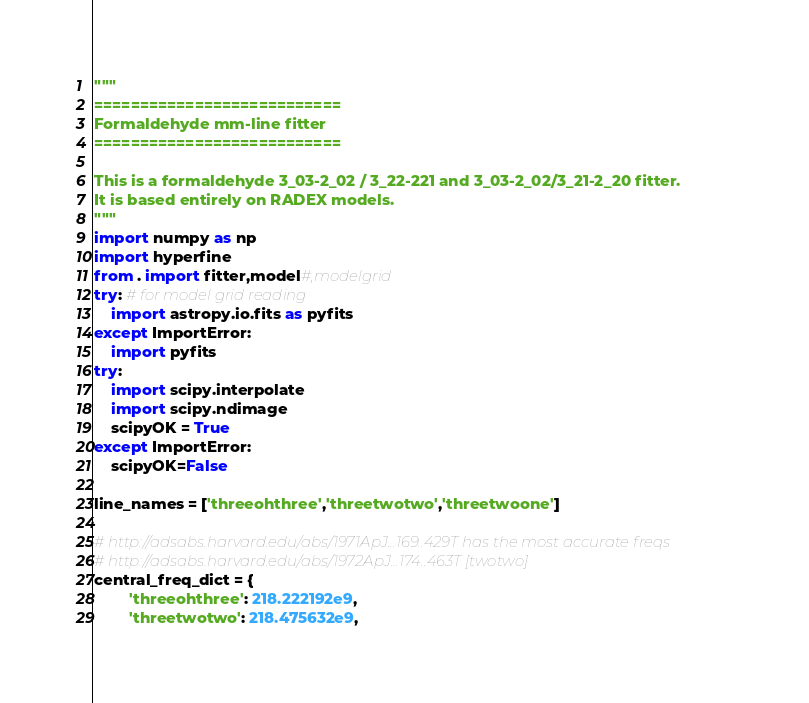Convert code to text. <code><loc_0><loc_0><loc_500><loc_500><_Python_>"""
===========================
Formaldehyde mm-line fitter
===========================

This is a formaldehyde 3_03-2_02 / 3_22-221 and 3_03-2_02/3_21-2_20 fitter.  
It is based entirely on RADEX models.
"""
import numpy as np
import hyperfine
from . import fitter,model#,modelgrid
try: # for model grid reading
    import astropy.io.fits as pyfits
except ImportError:
    import pyfits
try:
    import scipy.interpolate
    import scipy.ndimage
    scipyOK = True
except ImportError:
    scipyOK=False

line_names = ['threeohthree','threetwotwo','threetwoone']

# http://adsabs.harvard.edu/abs/1971ApJ...169..429T has the most accurate freqs
# http://adsabs.harvard.edu/abs/1972ApJ...174..463T [twotwo]
central_freq_dict = { 
        'threeohthree': 218.222192e9,
        'threetwotwo': 218.475632e9,</code> 